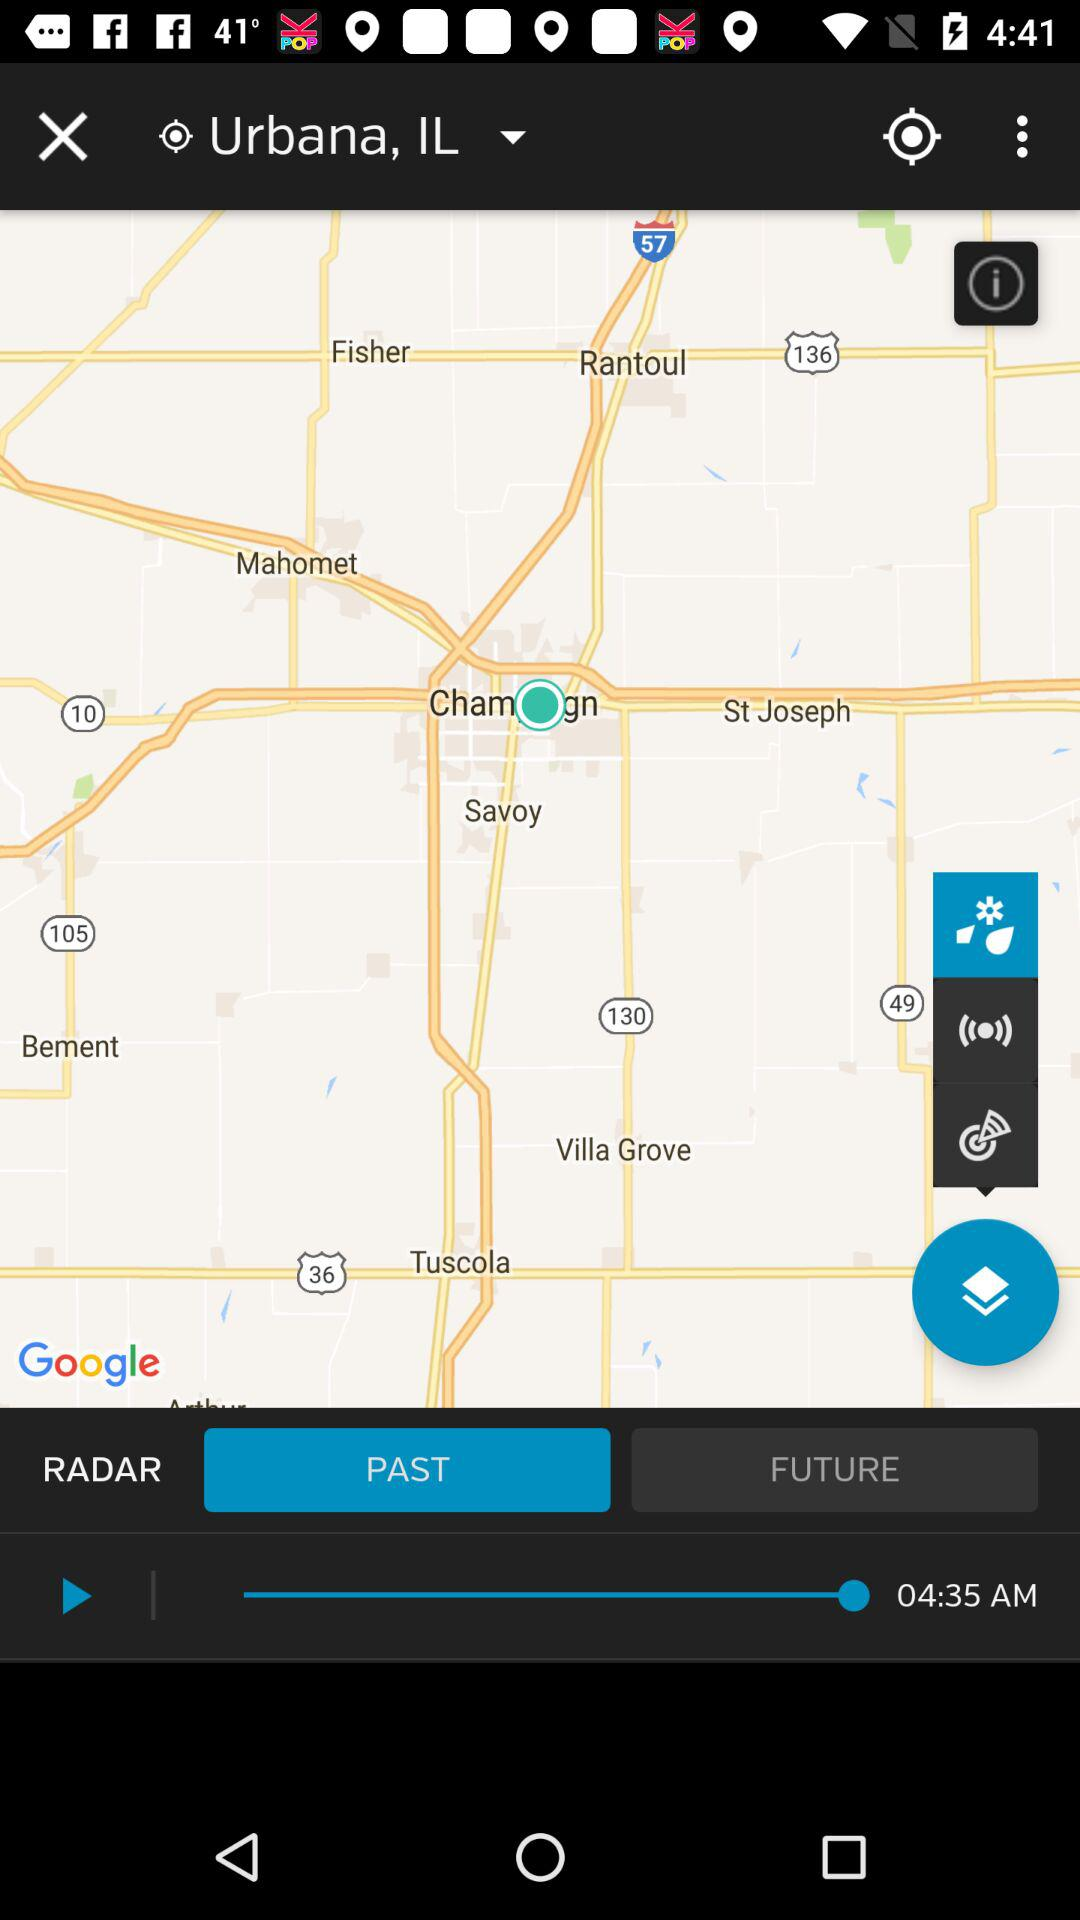What is the given time? The given time is 04:35 AM. 